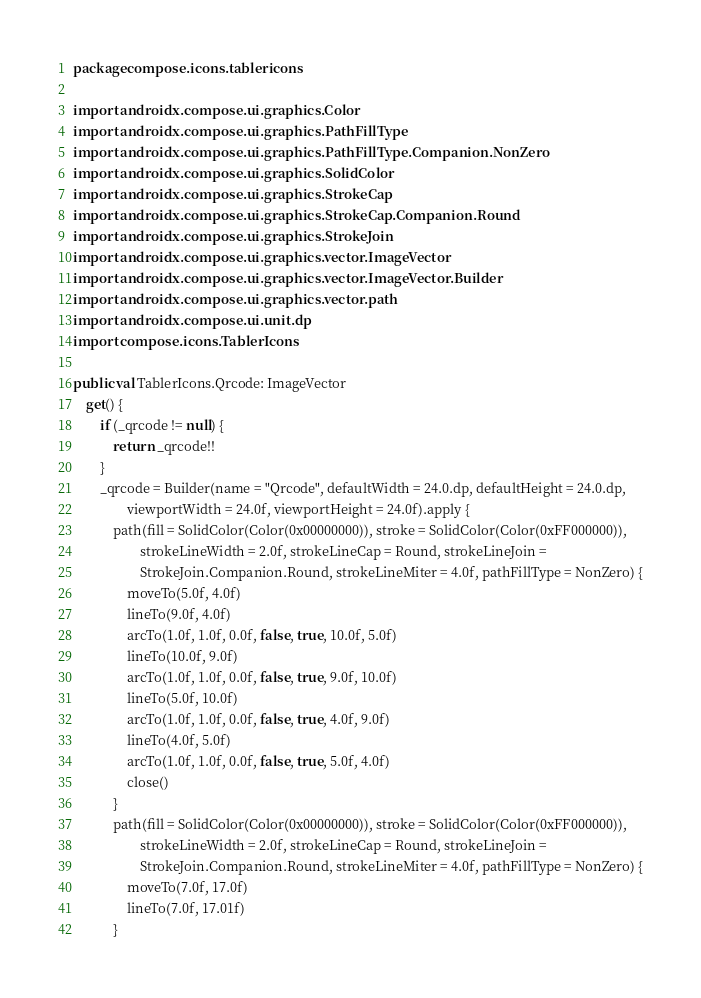<code> <loc_0><loc_0><loc_500><loc_500><_Kotlin_>package compose.icons.tablericons

import androidx.compose.ui.graphics.Color
import androidx.compose.ui.graphics.PathFillType
import androidx.compose.ui.graphics.PathFillType.Companion.NonZero
import androidx.compose.ui.graphics.SolidColor
import androidx.compose.ui.graphics.StrokeCap
import androidx.compose.ui.graphics.StrokeCap.Companion.Round
import androidx.compose.ui.graphics.StrokeJoin
import androidx.compose.ui.graphics.vector.ImageVector
import androidx.compose.ui.graphics.vector.ImageVector.Builder
import androidx.compose.ui.graphics.vector.path
import androidx.compose.ui.unit.dp
import compose.icons.TablerIcons

public val TablerIcons.Qrcode: ImageVector
    get() {
        if (_qrcode != null) {
            return _qrcode!!
        }
        _qrcode = Builder(name = "Qrcode", defaultWidth = 24.0.dp, defaultHeight = 24.0.dp,
                viewportWidth = 24.0f, viewportHeight = 24.0f).apply {
            path(fill = SolidColor(Color(0x00000000)), stroke = SolidColor(Color(0xFF000000)),
                    strokeLineWidth = 2.0f, strokeLineCap = Round, strokeLineJoin =
                    StrokeJoin.Companion.Round, strokeLineMiter = 4.0f, pathFillType = NonZero) {
                moveTo(5.0f, 4.0f)
                lineTo(9.0f, 4.0f)
                arcTo(1.0f, 1.0f, 0.0f, false, true, 10.0f, 5.0f)
                lineTo(10.0f, 9.0f)
                arcTo(1.0f, 1.0f, 0.0f, false, true, 9.0f, 10.0f)
                lineTo(5.0f, 10.0f)
                arcTo(1.0f, 1.0f, 0.0f, false, true, 4.0f, 9.0f)
                lineTo(4.0f, 5.0f)
                arcTo(1.0f, 1.0f, 0.0f, false, true, 5.0f, 4.0f)
                close()
            }
            path(fill = SolidColor(Color(0x00000000)), stroke = SolidColor(Color(0xFF000000)),
                    strokeLineWidth = 2.0f, strokeLineCap = Round, strokeLineJoin =
                    StrokeJoin.Companion.Round, strokeLineMiter = 4.0f, pathFillType = NonZero) {
                moveTo(7.0f, 17.0f)
                lineTo(7.0f, 17.01f)
            }</code> 